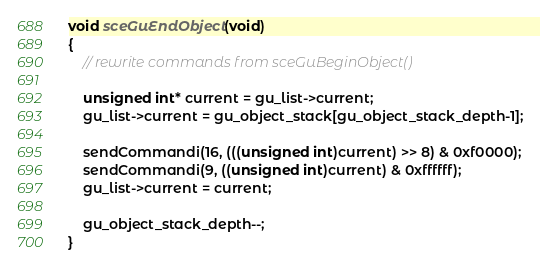<code> <loc_0><loc_0><loc_500><loc_500><_C_>
void sceGuEndObject(void)
{
	// rewrite commands from sceGuBeginObject()

	unsigned int* current = gu_list->current;
	gu_list->current = gu_object_stack[gu_object_stack_depth-1];

	sendCommandi(16, (((unsigned int)current) >> 8) & 0xf0000);
	sendCommandi(9, ((unsigned int)current) & 0xffffff);
	gu_list->current = current;

	gu_object_stack_depth--;
}
</code> 